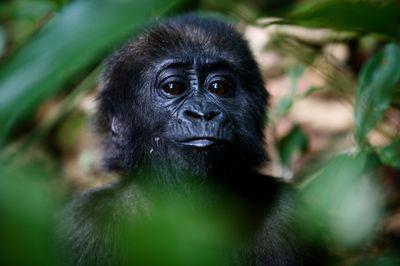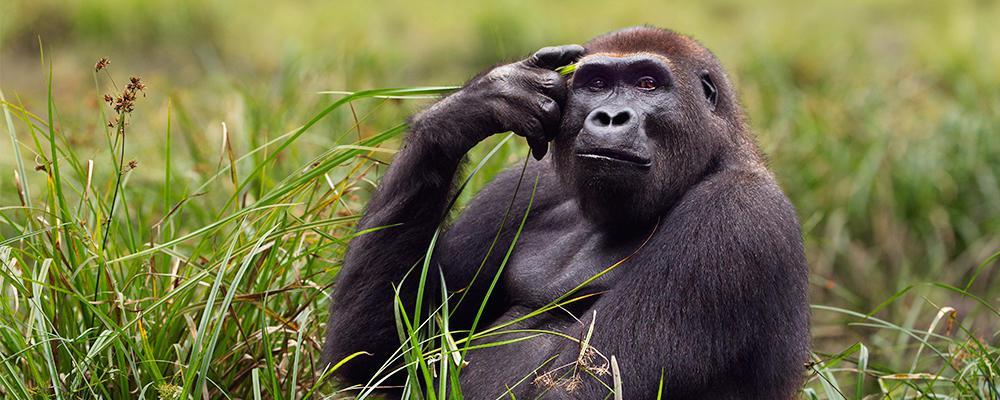The first image is the image on the left, the second image is the image on the right. Evaluate the accuracy of this statement regarding the images: "The gorilla in the right image rests its hand against part of its own body.". Is it true? Answer yes or no. Yes. 